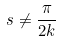<formula> <loc_0><loc_0><loc_500><loc_500>s \ne \frac { \pi } { 2 k }</formula> 